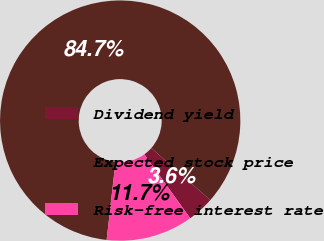Convert chart. <chart><loc_0><loc_0><loc_500><loc_500><pie_chart><fcel>Dividend yield<fcel>Expected stock price<fcel>Risk-free interest rate<nl><fcel>3.59%<fcel>84.7%<fcel>11.7%<nl></chart> 